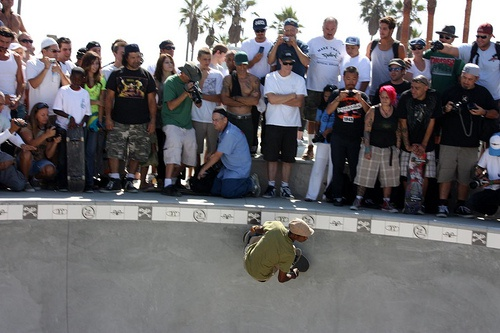Describe the objects in this image and their specific colors. I can see people in gray, black, maroon, and white tones, people in gray, black, and maroon tones, people in gray, black, darkgray, and lavender tones, people in gray, black, and darkgreen tones, and people in gray, darkgreen, black, and maroon tones in this image. 